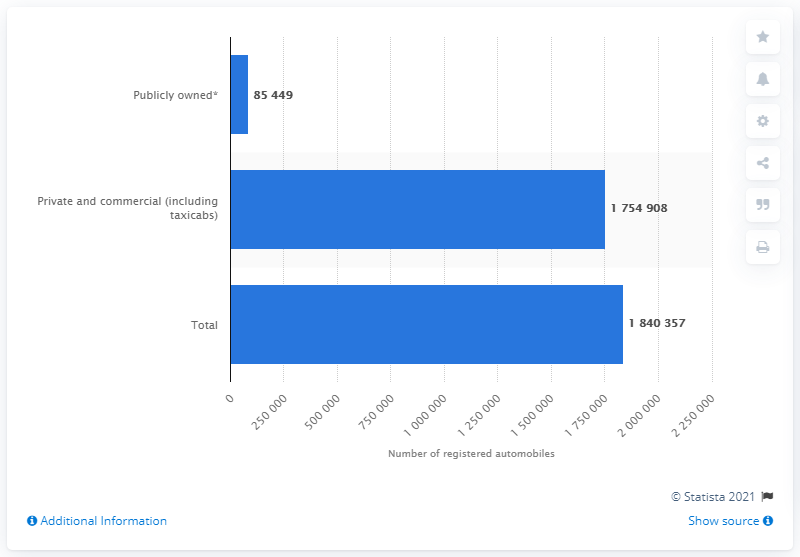Draw attention to some important aspects in this diagram. In South Carolina in 2016, a total of 175,490.8 private and commercial automobiles were registered. 